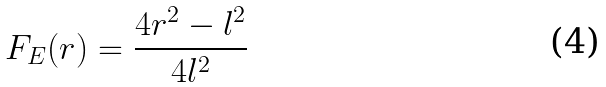<formula> <loc_0><loc_0><loc_500><loc_500>F _ { E } ( r ) = \frac { 4 r ^ { 2 } - l ^ { 2 } } { 4 l ^ { 2 } }</formula> 